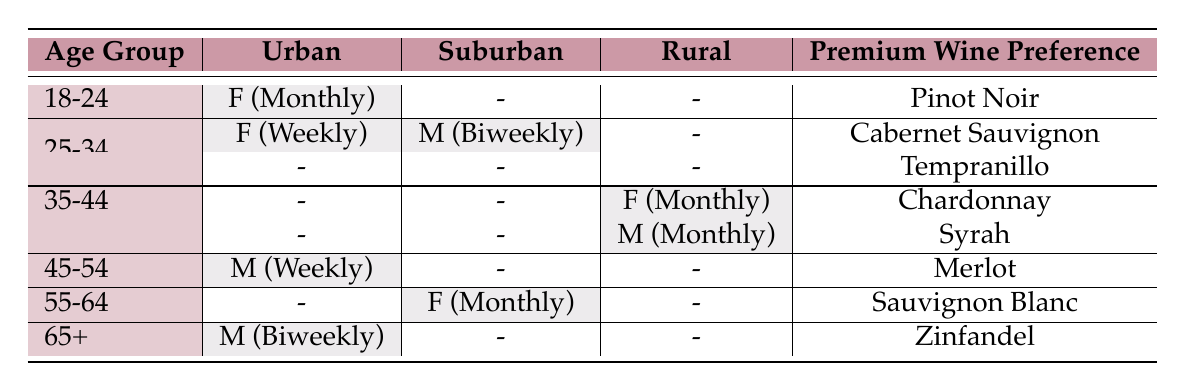What is the purchase frequency for customers aged 18-24 in urban areas? In the table, for the age group 18-24, the purchase frequency listed under Urban is "Monthly."
Answer: Monthly How many premium wine preferences are listed for customers aged 25-34? There are two entries for the age group 25-34 in the table: Cabernet Sauvignon and Tempranillo, thus there are a total of 2 premium wine preferences.
Answer: 2 Is there a male customer aged 55-64 who purchases premium wine? There is no male listed for the age group 55-64 in the table; it shows a female with a purchase frequency of "Monthly." Therefore, the answer is no.
Answer: No What is the combined number of customers aged 35-44 in rural and urban areas who prefer Chardonnay and Syrah? For the age group 35-44, there is one female in rural areas who prefers Chardonnay, and one male in urban areas who prefers Syrah, totaling 2 customers.
Answer: 2 What is the purchase frequency for female customers in suburban areas who prefer premium wines? There is one female customer aged 55-64 in suburban areas who purchases premium wine "Monthly," and there are no other female customers in suburban areas. Thus, the purchase frequency is "Monthly."
Answer: Monthly 